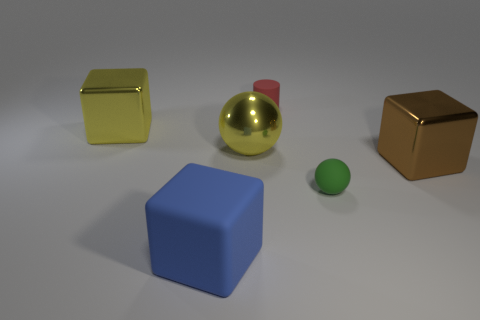There is an object that is the same color as the large ball; what is its material? The object sharing the same glossy gold color as the large ball appears to be a smaller cube. The material of this cube is likely to be a metal or a metallic-painted plastic, given its reflective surface and similarity to the ball's finishing. 